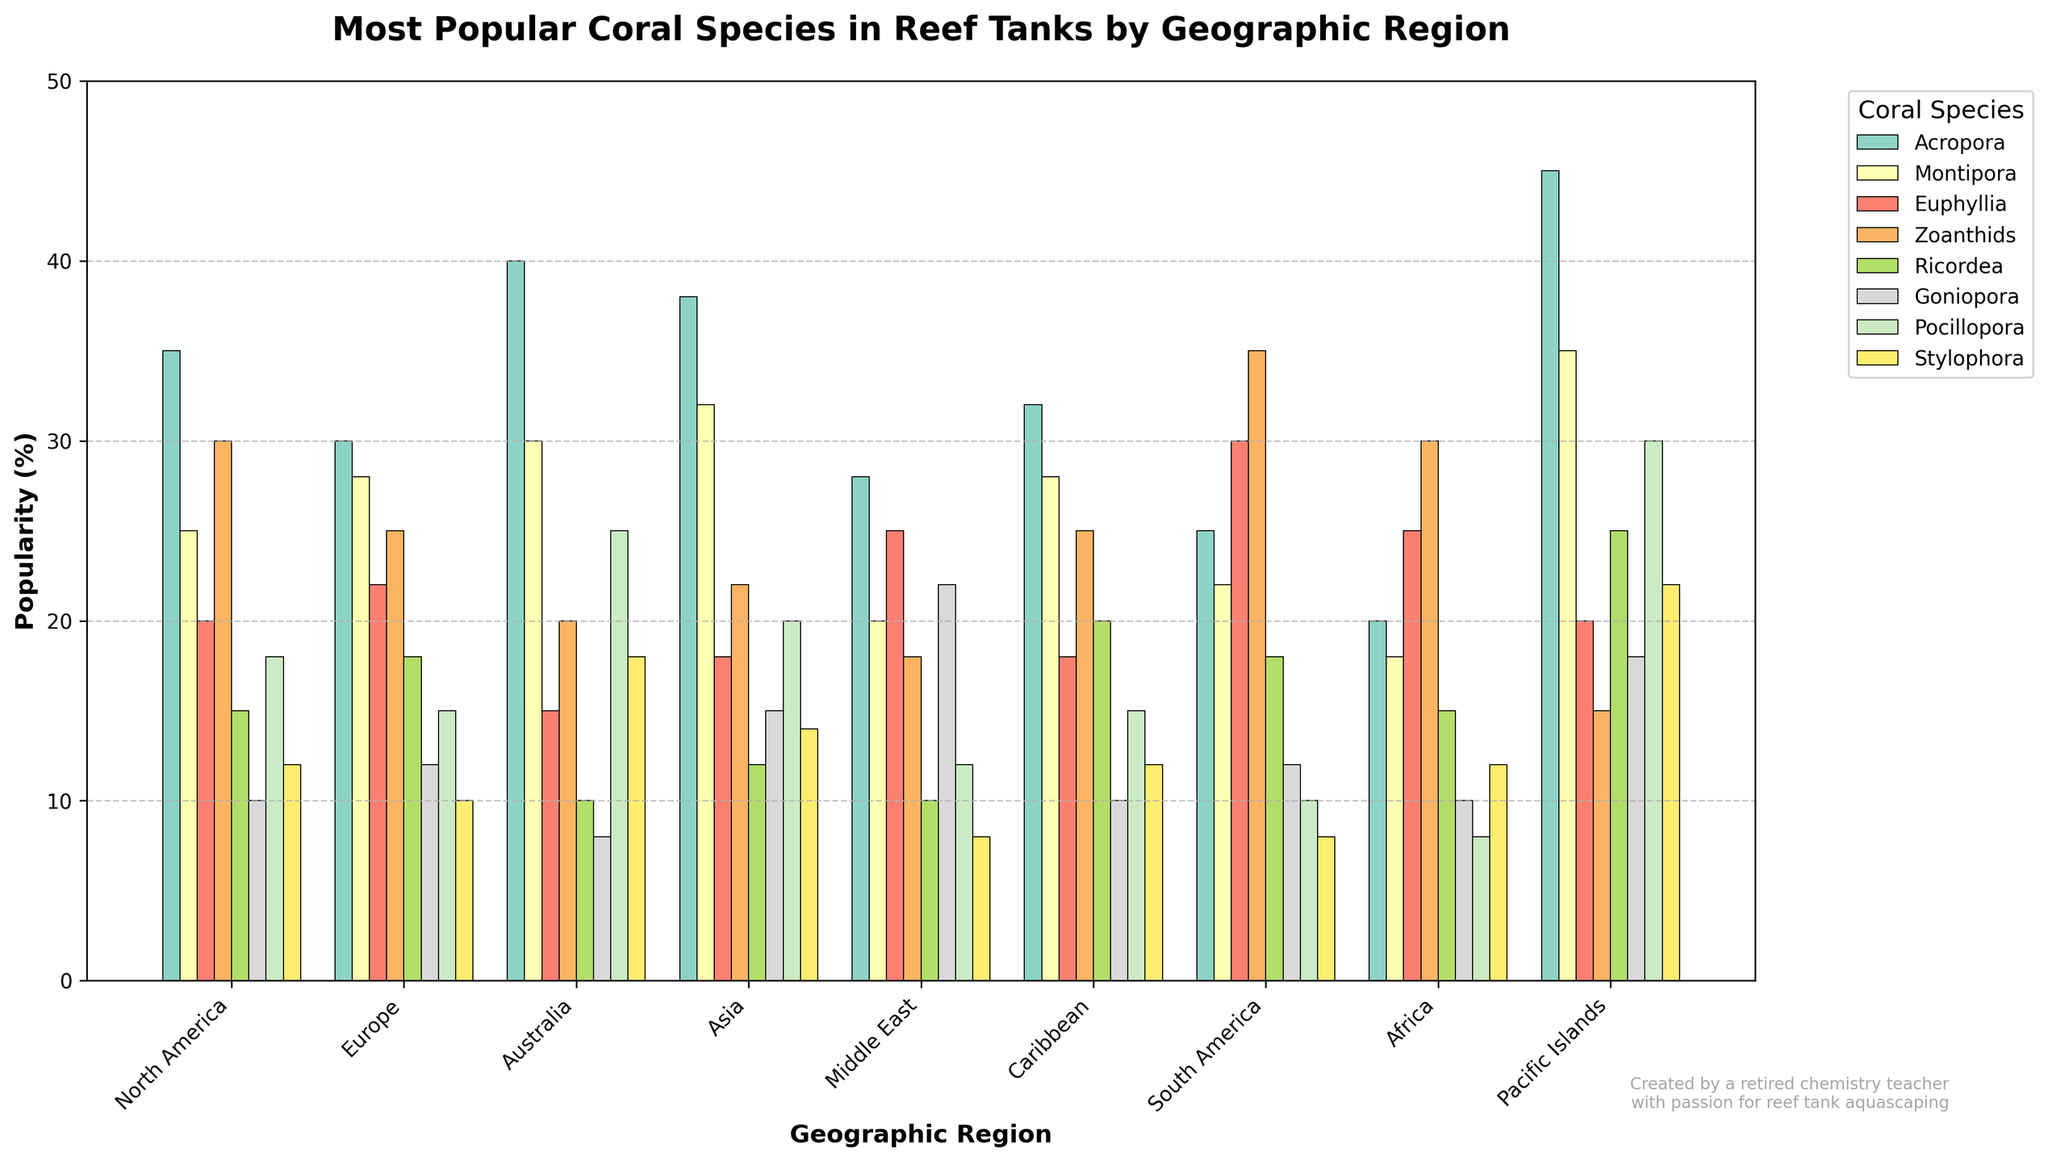What's the most popular coral species in North America? By examining the bar heights for North America, Acropora has the highest bar at 35%. Thus, the most popular coral species in North America is Acropora.
Answer: Acropora Which region has the highest popularity for Zoanthids? Looking at the bars for Zoanthids across all regions, South America has the highest bar at 35%. Thus, South America has the highest popularity for Zoanthids.
Answer: South America In Asia, which coral species is the least popular? The bars for Asia indicate that the least popular coral species in Asia is Goniopora with a bar height of 15%.
Answer: Goniopora Compare the popularity of Pocillopora in Australia and the Pacific Islands. Which region shows higher popularity? The bar for Pocillopora in the Pacific Islands is 30%, while in Australia it is 25%. Therefore, the Pacific Islands show higher popularity for Pocillopora.
Answer: Pacific Islands What’s the difference in popularity between Montipora and Ricordea in Europe? In Europe, the bar height for Montipora is 28% and for Ricordea is 18%. The difference is 28% - 18% = 10%.
Answer: 10% Which coral species is equally popular (in %) in both North America and Europe? Comparing the heights of the bars for North America and Europe, Montipora is 25% in North America and 28% in Europe. Since no species matches exactly in popularity, no species is equally popular in both regions.
Answer: None What is the average popularity of Goniopora across all regions? Sum the percentages for Goniopora in all regions: 10+12+8+15+22+10+12+10+18 = 117. There are 9 regions, so the average is 117/9 ≈ 13%.
Answer: 13% How does the popularity of Euphyllia compare between the Middle East and the Caribbean? The bar for Euphyllia is 25% in the Caribbean and 25% in the Middle East, making their popularity equal.
Answer: Equal Identify regions where the popularity of Stylophora is less than 10%. Checking the heights of the bars, the only region with Stylophora popularity less than 10% is the Middle East (8%).
Answer: Middle East Which coral species has the highest average popularity across all regions? To find the average popularity, sum the bars for each species and divide by 9 (number of regions). The highest totals will give the species with the highest average. By inspecting visually, Acropora seems to have the highest bars consistently across regions.
Answer: Acropora 